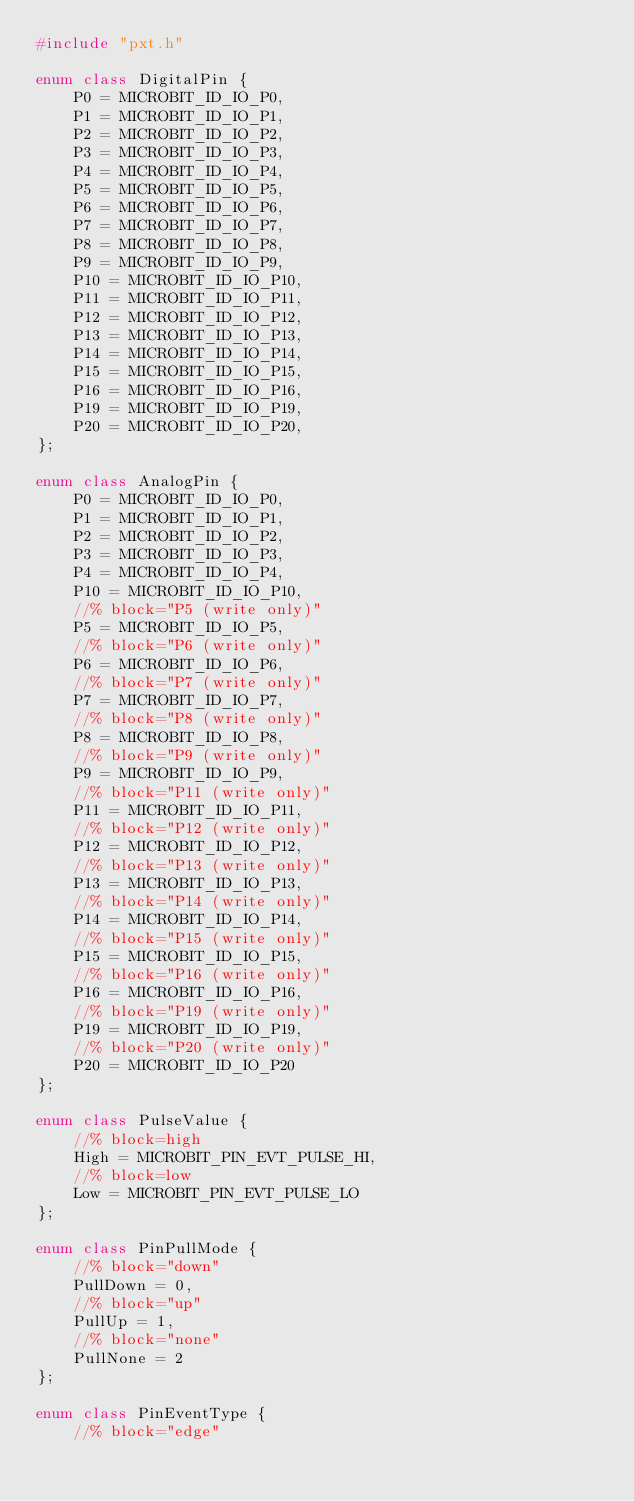<code> <loc_0><loc_0><loc_500><loc_500><_C++_>#include "pxt.h"

enum class DigitalPin {
    P0 = MICROBIT_ID_IO_P0,
    P1 = MICROBIT_ID_IO_P1,
    P2 = MICROBIT_ID_IO_P2,
    P3 = MICROBIT_ID_IO_P3,
    P4 = MICROBIT_ID_IO_P4,
    P5 = MICROBIT_ID_IO_P5,
    P6 = MICROBIT_ID_IO_P6,
    P7 = MICROBIT_ID_IO_P7,
    P8 = MICROBIT_ID_IO_P8,
    P9 = MICROBIT_ID_IO_P9,
    P10 = MICROBIT_ID_IO_P10,
    P11 = MICROBIT_ID_IO_P11,
    P12 = MICROBIT_ID_IO_P12,
    P13 = MICROBIT_ID_IO_P13,
    P14 = MICROBIT_ID_IO_P14,
    P15 = MICROBIT_ID_IO_P15,
    P16 = MICROBIT_ID_IO_P16,
    P19 = MICROBIT_ID_IO_P19,
    P20 = MICROBIT_ID_IO_P20,
};

enum class AnalogPin {
    P0 = MICROBIT_ID_IO_P0,
    P1 = MICROBIT_ID_IO_P1,
    P2 = MICROBIT_ID_IO_P2,
    P3 = MICROBIT_ID_IO_P3,
    P4 = MICROBIT_ID_IO_P4,
    P10 = MICROBIT_ID_IO_P10,
    //% block="P5 (write only)"
    P5 = MICROBIT_ID_IO_P5,
    //% block="P6 (write only)"
    P6 = MICROBIT_ID_IO_P6,
    //% block="P7 (write only)"
    P7 = MICROBIT_ID_IO_P7,
    //% block="P8 (write only)"
    P8 = MICROBIT_ID_IO_P8,
    //% block="P9 (write only)"
    P9 = MICROBIT_ID_IO_P9,
    //% block="P11 (write only)"
    P11 = MICROBIT_ID_IO_P11,
    //% block="P12 (write only)"
    P12 = MICROBIT_ID_IO_P12,
    //% block="P13 (write only)"
    P13 = MICROBIT_ID_IO_P13,
    //% block="P14 (write only)"
    P14 = MICROBIT_ID_IO_P14,
    //% block="P15 (write only)"
    P15 = MICROBIT_ID_IO_P15,
    //% block="P16 (write only)"
    P16 = MICROBIT_ID_IO_P16,
    //% block="P19 (write only)"
    P19 = MICROBIT_ID_IO_P19,
    //% block="P20 (write only)"
    P20 = MICROBIT_ID_IO_P20
};

enum class PulseValue {
    //% block=high
    High = MICROBIT_PIN_EVT_PULSE_HI,
    //% block=low
    Low = MICROBIT_PIN_EVT_PULSE_LO
};

enum class PinPullMode {
    //% block="down"
    PullDown = 0,
    //% block="up"
    PullUp = 1,
    //% block="none"
    PullNone = 2
};

enum class PinEventType {
    //% block="edge"</code> 